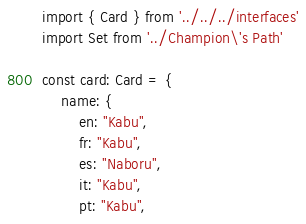Convert code to text. <code><loc_0><loc_0><loc_500><loc_500><_TypeScript_>import { Card } from '../../../interfaces'
import Set from '../Champion\'s Path'

const card: Card = {
	name: {
		en: "Kabu",
		fr: "Kabu",
		es: "Naboru",
		it: "Kabu",
		pt: "Kabu",</code> 